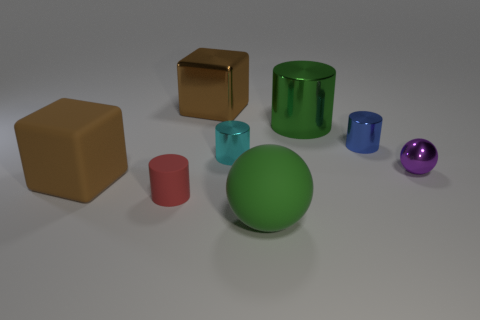Subtract all purple cylinders. Subtract all blue balls. How many cylinders are left? 4 Add 1 small cyan rubber spheres. How many objects exist? 9 Subtract all cubes. How many objects are left? 6 Subtract 0 red cubes. How many objects are left? 8 Subtract all small cyan rubber balls. Subtract all big brown metallic blocks. How many objects are left? 7 Add 5 green rubber spheres. How many green rubber spheres are left? 6 Add 6 big objects. How many big objects exist? 10 